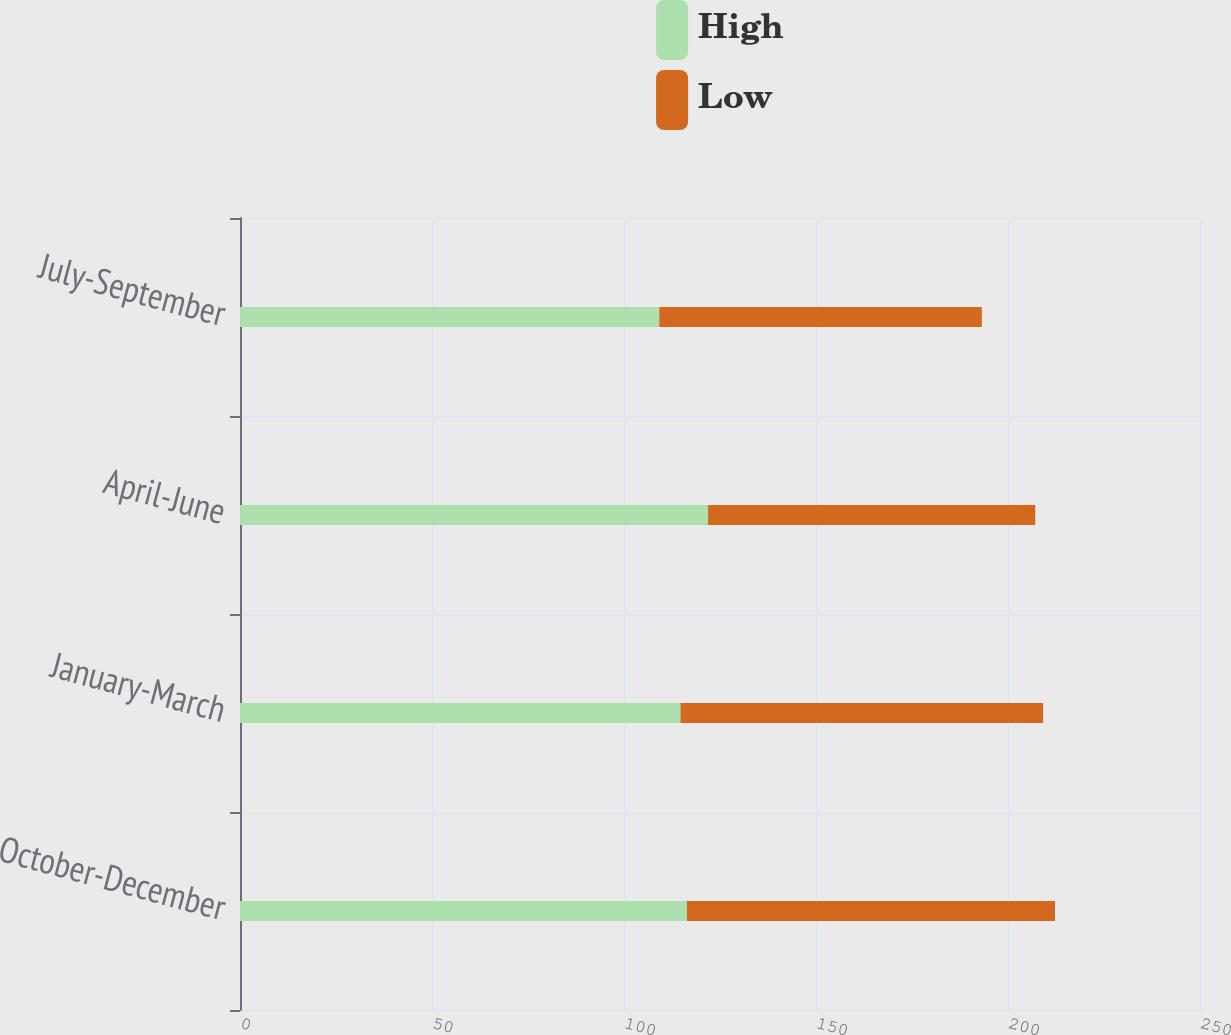Convert chart to OTSL. <chart><loc_0><loc_0><loc_500><loc_500><stacked_bar_chart><ecel><fcel>October-December<fcel>January-March<fcel>April-June<fcel>July-September<nl><fcel>High<fcel>116.38<fcel>114.71<fcel>121.89<fcel>109.19<nl><fcel>Low<fcel>95.86<fcel>94.43<fcel>85.2<fcel>84<nl></chart> 